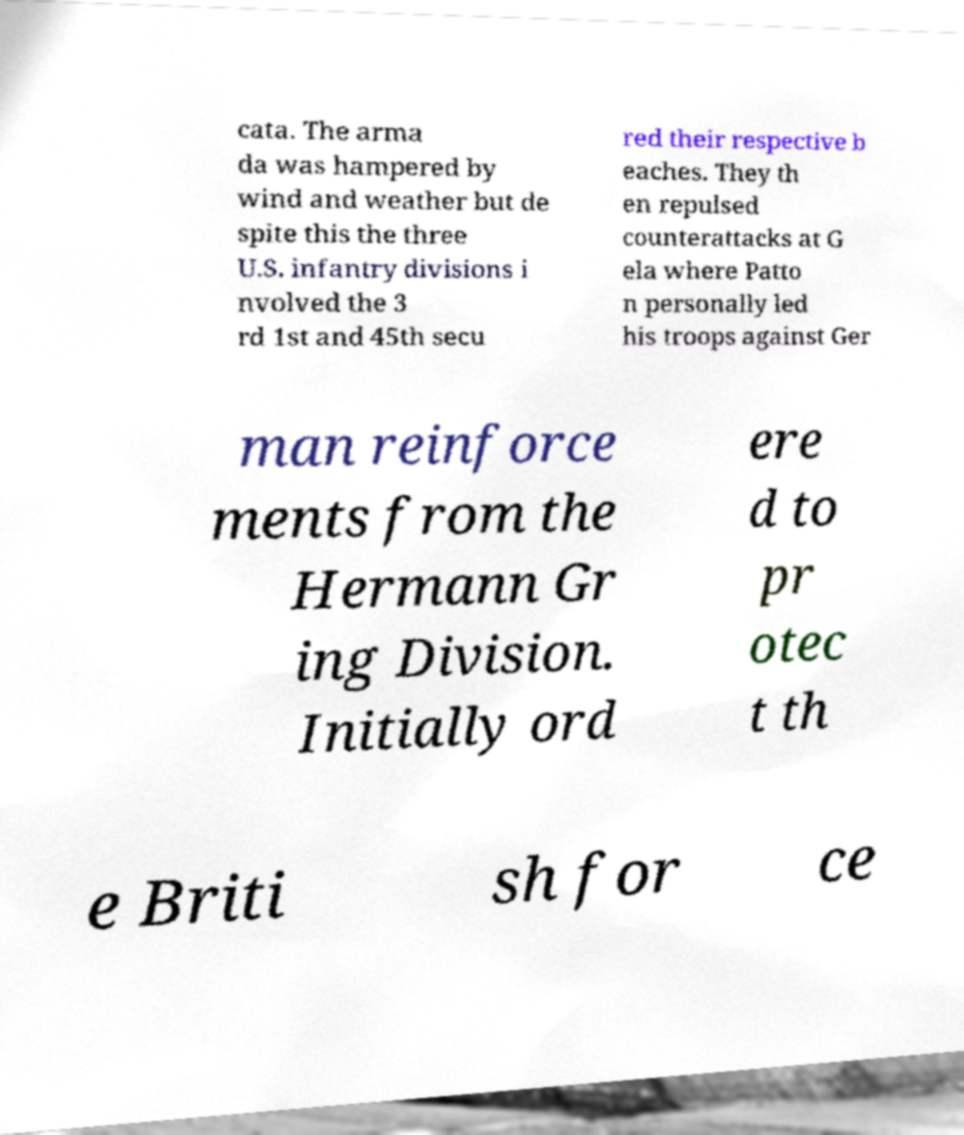There's text embedded in this image that I need extracted. Can you transcribe it verbatim? cata. The arma da was hampered by wind and weather but de spite this the three U.S. infantry divisions i nvolved the 3 rd 1st and 45th secu red their respective b eaches. They th en repulsed counterattacks at G ela where Patto n personally led his troops against Ger man reinforce ments from the Hermann Gr ing Division. Initially ord ere d to pr otec t th e Briti sh for ce 